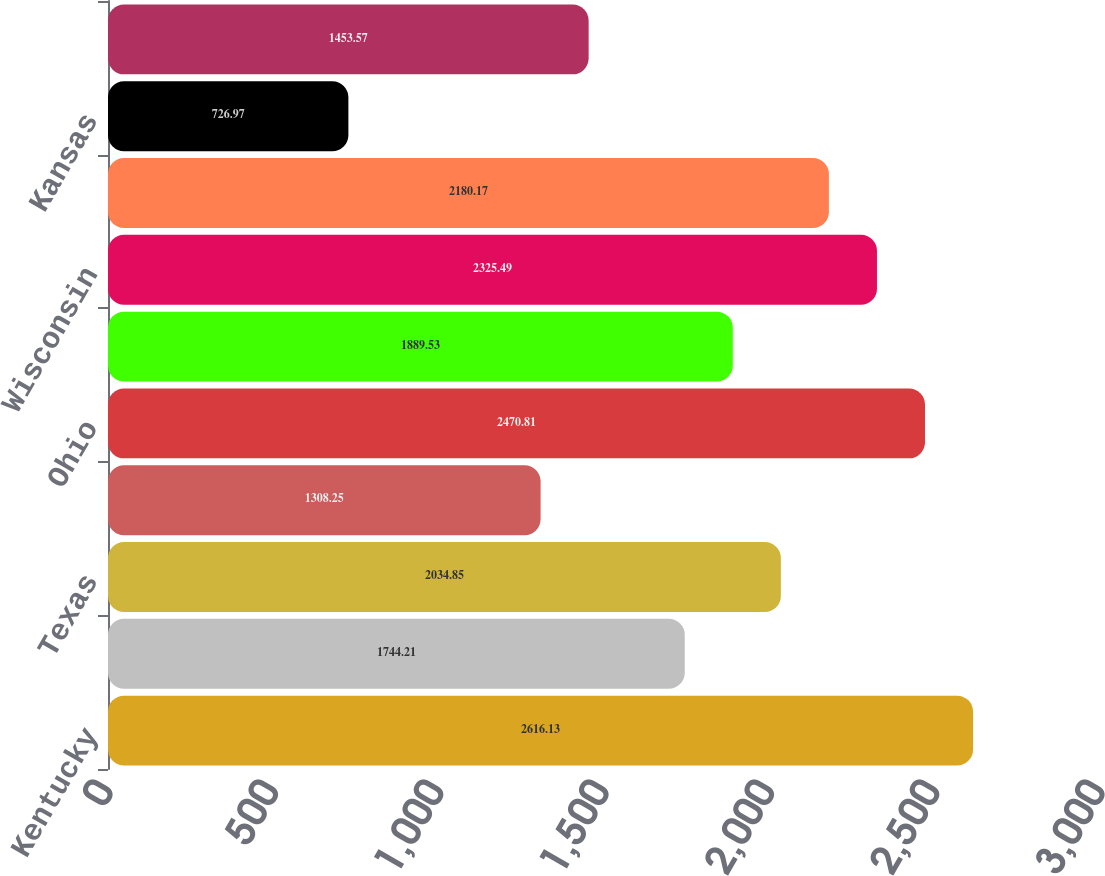Convert chart to OTSL. <chart><loc_0><loc_0><loc_500><loc_500><bar_chart><fcel>Kentucky<fcel>Florida<fcel>Texas<fcel>Rico<fcel>Ohio<fcel>Illinois<fcel>Wisconsin<fcel>Tennessee<fcel>Kansas<fcel>Georgia<nl><fcel>2616.13<fcel>1744.21<fcel>2034.85<fcel>1308.25<fcel>2470.81<fcel>1889.53<fcel>2325.49<fcel>2180.17<fcel>726.97<fcel>1453.57<nl></chart> 